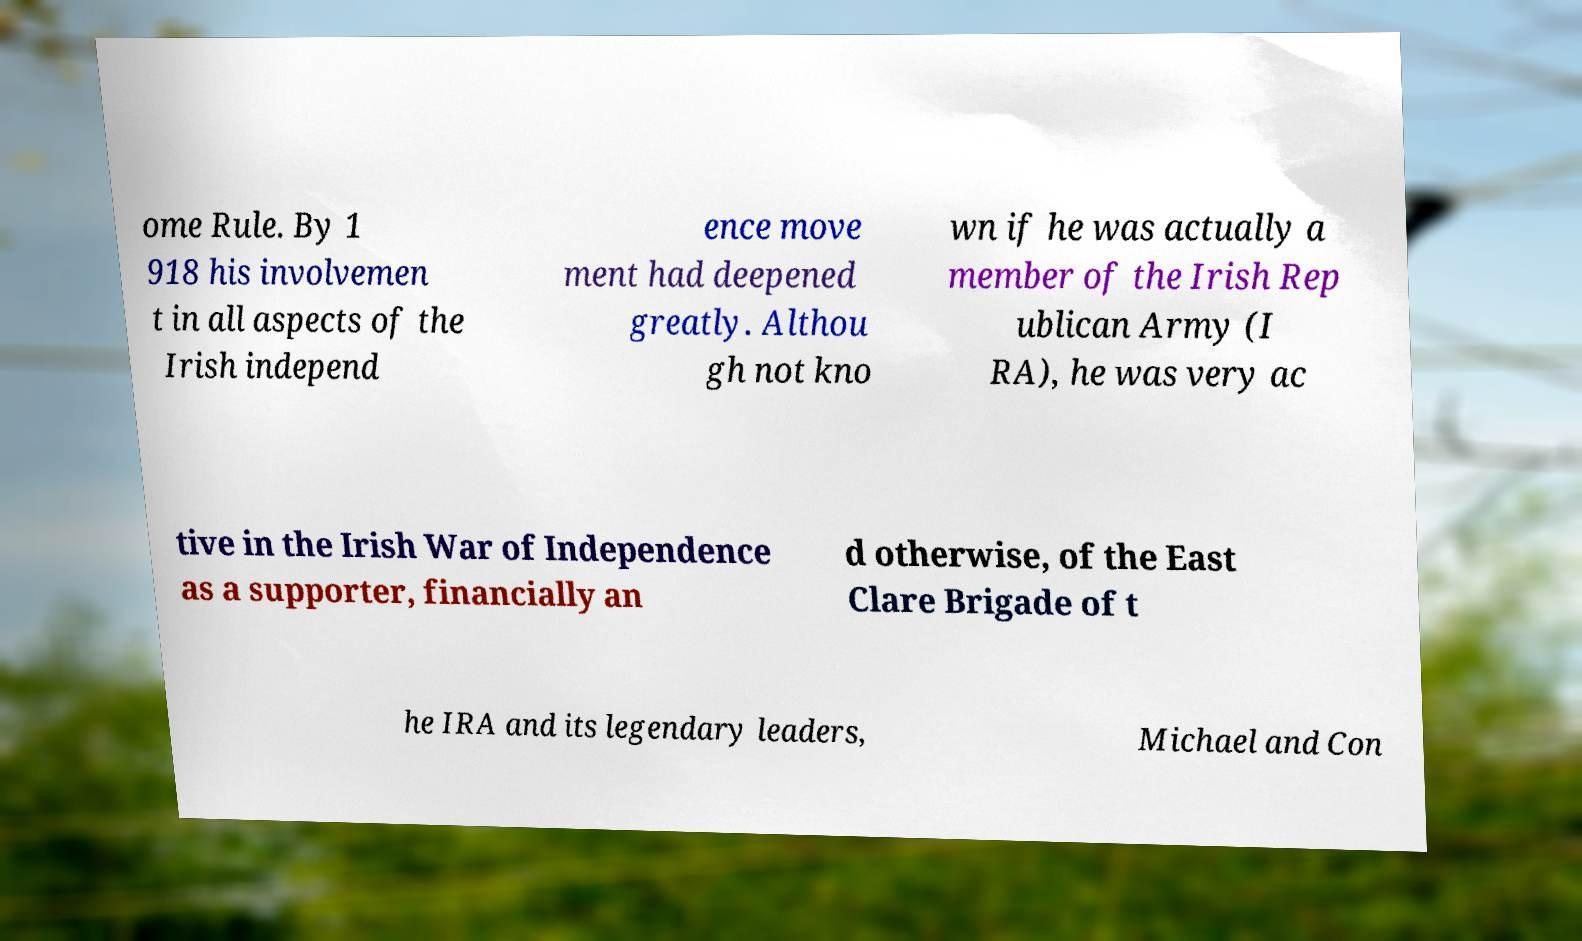Can you accurately transcribe the text from the provided image for me? ome Rule. By 1 918 his involvemen t in all aspects of the Irish independ ence move ment had deepened greatly. Althou gh not kno wn if he was actually a member of the Irish Rep ublican Army (I RA), he was very ac tive in the Irish War of Independence as a supporter, financially an d otherwise, of the East Clare Brigade of t he IRA and its legendary leaders, Michael and Con 